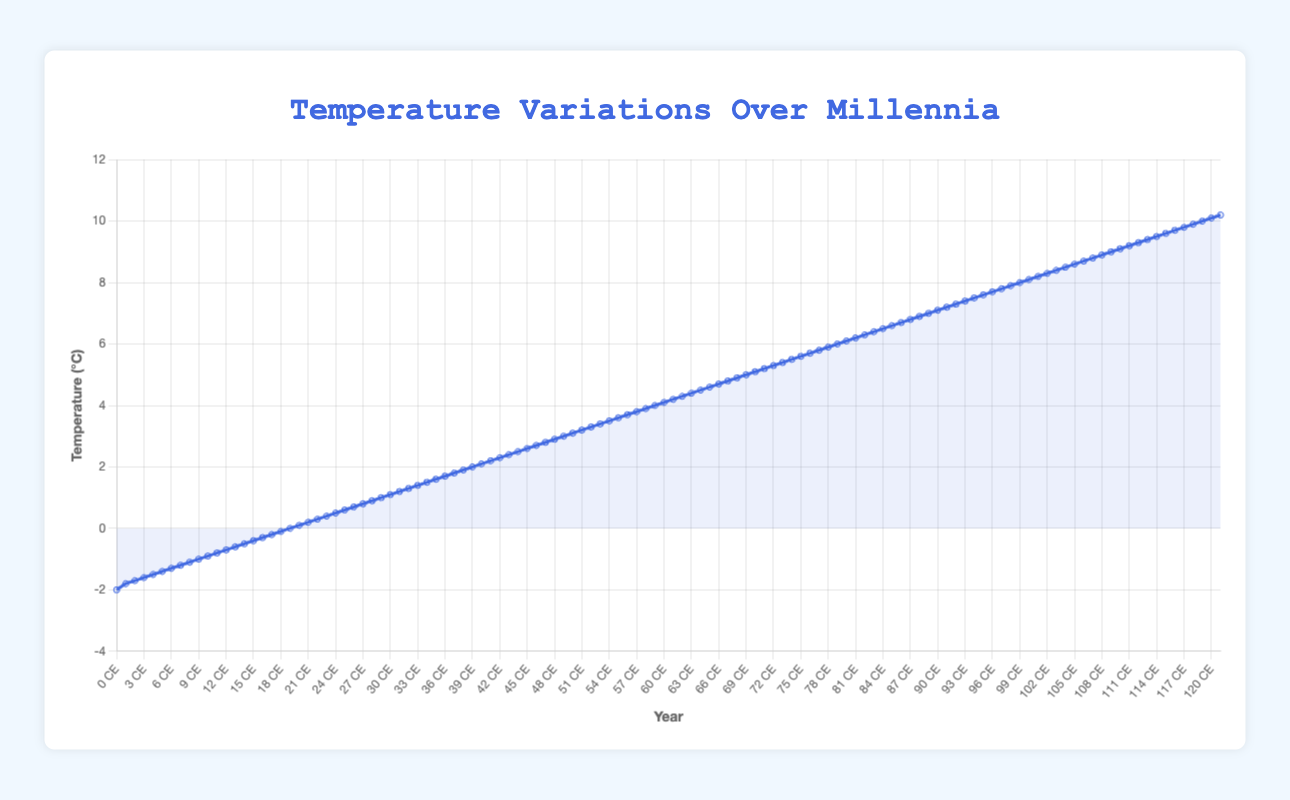What is the average temperature in the decade -3000? To find the average temperature in the decade -3000, look at the data point for that decade specifically. The graph shows that the average temperature for the decade -3000 is 5.1°C.
Answer: 5.1°C Which millennium (1000-year period) shows the highest increase in average temperature? Calculate the difference in temperature between the start and end of each millennium and compare them. The millennium from -10000 to -9000 shows a change from -2.0°C to -0.9°C, a 1.1°C increase. However, the millennium from 1000 to 2000 shows a change from 9.1°C to 10.1°C, a 1.0°C increase. Therefore, the period from -8000 to -7000 (0.1°C to 1.1°C) shows the highest increase of 1°C within a full 1000-year span.
Answer: -8000 to -7000 BCE How does the temperature in 0 CE compare to that in -900 BCE? To compare the temperatures, find the data points corresponding to 0 CE and -900 BCE. In 0 CE, the average temperature is 8.1°C. In -900 BCE, the average temperature is 7.2°C. So, 0 CE is warmer by 0.9°C.
Answer: 0.9°C warmer During which century (100-year period) did the temperature reach 9.0°C? Check the data points to determine when the average temperature first hits 9.0°C. The data point at 900 CE shows an average temperature of 9.0°C, indicating it first reaches this level during the 9th century.
Answer: 9th century What is the temperature trend between -3000 and 500 CE? Inspect the line segment between these years on the graph. From -3000, the temperature is 5.1°C, and it increases to 8.6°C by 500 CE. There's a steady upward trend of 3.5°C over this period.
Answer: Increasing trend If the temperature in -10000 BCE was -2.0°C, what was the temperature difference by -6000 BCE? To find the temperature difference between these two periods, subtract the temperature at -6000 BCE from the temperature at -10000 BCE. The temperatures are -2.0°C and 2.1°C respectively. So, the difference is: 2.1 - (-2.0) = 4.1°C
Answer: 4.1°C What visual change occurs on the graph's y-axis as temperature increases from -2000 to 2000 CE? Observe the vertical climb of the line on the y-axis. The temperature increases from 6.1°C in -2000 to 10.1°C in 2000, showing a major visual upward slope over these millennia.
Answer: Upward slope Which period, -2000 to -1000 BCE or 1000 to 2000 CE, has a greater temperature increase? Calculate the temperature increase for both periods. From -2000 to -1000, the temperature goes from 6.1°C to 7.1°C, a 1.0°C increase. From 1000 to 2000, it increases from 9.1°C to 10.1°C, also a 1.0°C increase.
Answer: Equal increase What is the temperature difference between 0 CE and 2010 CE? Find the temperatures for these two years on the graph. In 0 CE, the average temperature is 8.1°C. In 2010 CE, the average temperature is 10.2°C. The difference is: 10.2 - 8.1 = 2.1°C.
Answer: 2.1°C What is the median temperature value of the data points shown? To find the median, list all temperature values in ascending order and find the middle one. If there’s an even number of data points, take the average of the two middle numbers. Here, the number of data points is 120, the two middle values at positions 60 and 61 are 4.0°C and 4.1°C, respectively. The median is (4.0 + 4.1)/2 = 4.05°C.
Answer: 4.05°C 